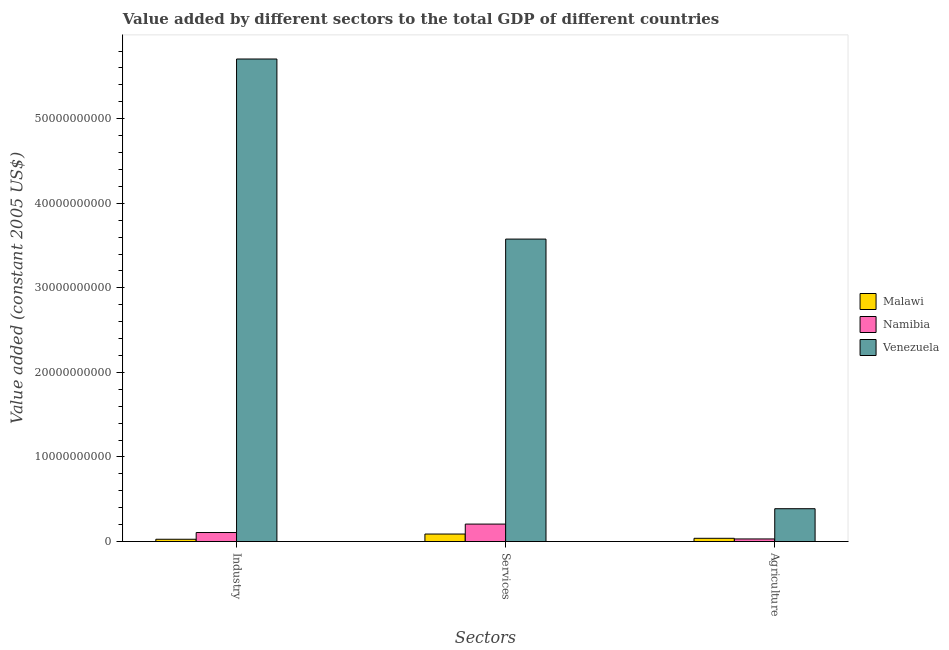How many different coloured bars are there?
Make the answer very short. 3. How many groups of bars are there?
Your answer should be very brief. 3. Are the number of bars per tick equal to the number of legend labels?
Your answer should be compact. Yes. Are the number of bars on each tick of the X-axis equal?
Make the answer very short. Yes. What is the label of the 1st group of bars from the left?
Provide a succinct answer. Industry. What is the value added by industrial sector in Venezuela?
Keep it short and to the point. 5.71e+1. Across all countries, what is the maximum value added by services?
Provide a short and direct response. 3.58e+1. Across all countries, what is the minimum value added by industrial sector?
Provide a short and direct response. 2.72e+08. In which country was the value added by industrial sector maximum?
Your answer should be compact. Venezuela. In which country was the value added by agricultural sector minimum?
Ensure brevity in your answer.  Namibia. What is the total value added by agricultural sector in the graph?
Offer a terse response. 4.58e+09. What is the difference between the value added by services in Venezuela and that in Namibia?
Offer a terse response. 3.37e+1. What is the difference between the value added by industrial sector in Venezuela and the value added by services in Namibia?
Give a very brief answer. 5.50e+1. What is the average value added by services per country?
Your answer should be very brief. 1.29e+1. What is the difference between the value added by services and value added by industrial sector in Venezuela?
Ensure brevity in your answer.  -2.13e+1. What is the ratio of the value added by services in Venezuela to that in Namibia?
Your answer should be compact. 17.31. Is the value added by industrial sector in Malawi less than that in Namibia?
Ensure brevity in your answer.  Yes. Is the difference between the value added by industrial sector in Venezuela and Malawi greater than the difference between the value added by agricultural sector in Venezuela and Malawi?
Provide a short and direct response. Yes. What is the difference between the highest and the second highest value added by services?
Provide a short and direct response. 3.37e+1. What is the difference between the highest and the lowest value added by services?
Keep it short and to the point. 3.49e+1. In how many countries, is the value added by industrial sector greater than the average value added by industrial sector taken over all countries?
Ensure brevity in your answer.  1. Is the sum of the value added by services in Venezuela and Namibia greater than the maximum value added by industrial sector across all countries?
Make the answer very short. No. What does the 3rd bar from the left in Services represents?
Offer a terse response. Venezuela. What does the 3rd bar from the right in Agriculture represents?
Ensure brevity in your answer.  Malawi. How many bars are there?
Provide a succinct answer. 9. Are all the bars in the graph horizontal?
Provide a short and direct response. No. Does the graph contain any zero values?
Your response must be concise. No. Does the graph contain grids?
Offer a terse response. No. What is the title of the graph?
Give a very brief answer. Value added by different sectors to the total GDP of different countries. Does "Benin" appear as one of the legend labels in the graph?
Your answer should be very brief. No. What is the label or title of the X-axis?
Your answer should be compact. Sectors. What is the label or title of the Y-axis?
Ensure brevity in your answer.  Value added (constant 2005 US$). What is the Value added (constant 2005 US$) in Malawi in Industry?
Offer a terse response. 2.72e+08. What is the Value added (constant 2005 US$) in Namibia in Industry?
Offer a terse response. 1.07e+09. What is the Value added (constant 2005 US$) in Venezuela in Industry?
Ensure brevity in your answer.  5.71e+1. What is the Value added (constant 2005 US$) in Malawi in Services?
Ensure brevity in your answer.  8.89e+08. What is the Value added (constant 2005 US$) in Namibia in Services?
Provide a succinct answer. 2.07e+09. What is the Value added (constant 2005 US$) of Venezuela in Services?
Provide a succinct answer. 3.58e+1. What is the Value added (constant 2005 US$) in Malawi in Agriculture?
Offer a very short reply. 3.84e+08. What is the Value added (constant 2005 US$) in Namibia in Agriculture?
Ensure brevity in your answer.  3.09e+08. What is the Value added (constant 2005 US$) in Venezuela in Agriculture?
Offer a terse response. 3.88e+09. Across all Sectors, what is the maximum Value added (constant 2005 US$) of Malawi?
Your response must be concise. 8.89e+08. Across all Sectors, what is the maximum Value added (constant 2005 US$) in Namibia?
Offer a very short reply. 2.07e+09. Across all Sectors, what is the maximum Value added (constant 2005 US$) of Venezuela?
Offer a very short reply. 5.71e+1. Across all Sectors, what is the minimum Value added (constant 2005 US$) of Malawi?
Your answer should be very brief. 2.72e+08. Across all Sectors, what is the minimum Value added (constant 2005 US$) of Namibia?
Offer a terse response. 3.09e+08. Across all Sectors, what is the minimum Value added (constant 2005 US$) in Venezuela?
Provide a succinct answer. 3.88e+09. What is the total Value added (constant 2005 US$) of Malawi in the graph?
Give a very brief answer. 1.55e+09. What is the total Value added (constant 2005 US$) in Namibia in the graph?
Your answer should be very brief. 3.44e+09. What is the total Value added (constant 2005 US$) of Venezuela in the graph?
Your answer should be compact. 9.67e+1. What is the difference between the Value added (constant 2005 US$) in Malawi in Industry and that in Services?
Your response must be concise. -6.18e+08. What is the difference between the Value added (constant 2005 US$) of Namibia in Industry and that in Services?
Make the answer very short. -9.97e+08. What is the difference between the Value added (constant 2005 US$) in Venezuela in Industry and that in Services?
Offer a very short reply. 2.13e+1. What is the difference between the Value added (constant 2005 US$) in Malawi in Industry and that in Agriculture?
Give a very brief answer. -1.13e+08. What is the difference between the Value added (constant 2005 US$) of Namibia in Industry and that in Agriculture?
Make the answer very short. 7.60e+08. What is the difference between the Value added (constant 2005 US$) in Venezuela in Industry and that in Agriculture?
Your response must be concise. 5.32e+1. What is the difference between the Value added (constant 2005 US$) in Malawi in Services and that in Agriculture?
Provide a succinct answer. 5.05e+08. What is the difference between the Value added (constant 2005 US$) of Namibia in Services and that in Agriculture?
Your answer should be compact. 1.76e+09. What is the difference between the Value added (constant 2005 US$) of Venezuela in Services and that in Agriculture?
Your answer should be compact. 3.19e+1. What is the difference between the Value added (constant 2005 US$) in Malawi in Industry and the Value added (constant 2005 US$) in Namibia in Services?
Provide a succinct answer. -1.79e+09. What is the difference between the Value added (constant 2005 US$) in Malawi in Industry and the Value added (constant 2005 US$) in Venezuela in Services?
Keep it short and to the point. -3.55e+1. What is the difference between the Value added (constant 2005 US$) in Namibia in Industry and the Value added (constant 2005 US$) in Venezuela in Services?
Keep it short and to the point. -3.47e+1. What is the difference between the Value added (constant 2005 US$) in Malawi in Industry and the Value added (constant 2005 US$) in Namibia in Agriculture?
Your response must be concise. -3.72e+07. What is the difference between the Value added (constant 2005 US$) in Malawi in Industry and the Value added (constant 2005 US$) in Venezuela in Agriculture?
Offer a very short reply. -3.61e+09. What is the difference between the Value added (constant 2005 US$) of Namibia in Industry and the Value added (constant 2005 US$) of Venezuela in Agriculture?
Make the answer very short. -2.81e+09. What is the difference between the Value added (constant 2005 US$) in Malawi in Services and the Value added (constant 2005 US$) in Namibia in Agriculture?
Provide a short and direct response. 5.80e+08. What is the difference between the Value added (constant 2005 US$) of Malawi in Services and the Value added (constant 2005 US$) of Venezuela in Agriculture?
Your answer should be compact. -2.99e+09. What is the difference between the Value added (constant 2005 US$) in Namibia in Services and the Value added (constant 2005 US$) in Venezuela in Agriculture?
Make the answer very short. -1.82e+09. What is the average Value added (constant 2005 US$) in Malawi per Sectors?
Keep it short and to the point. 5.15e+08. What is the average Value added (constant 2005 US$) of Namibia per Sectors?
Keep it short and to the point. 1.15e+09. What is the average Value added (constant 2005 US$) of Venezuela per Sectors?
Give a very brief answer. 3.22e+1. What is the difference between the Value added (constant 2005 US$) in Malawi and Value added (constant 2005 US$) in Namibia in Industry?
Your answer should be very brief. -7.97e+08. What is the difference between the Value added (constant 2005 US$) in Malawi and Value added (constant 2005 US$) in Venezuela in Industry?
Keep it short and to the point. -5.68e+1. What is the difference between the Value added (constant 2005 US$) in Namibia and Value added (constant 2005 US$) in Venezuela in Industry?
Your response must be concise. -5.60e+1. What is the difference between the Value added (constant 2005 US$) in Malawi and Value added (constant 2005 US$) in Namibia in Services?
Your response must be concise. -1.18e+09. What is the difference between the Value added (constant 2005 US$) of Malawi and Value added (constant 2005 US$) of Venezuela in Services?
Your answer should be compact. -3.49e+1. What is the difference between the Value added (constant 2005 US$) in Namibia and Value added (constant 2005 US$) in Venezuela in Services?
Offer a terse response. -3.37e+1. What is the difference between the Value added (constant 2005 US$) in Malawi and Value added (constant 2005 US$) in Namibia in Agriculture?
Give a very brief answer. 7.54e+07. What is the difference between the Value added (constant 2005 US$) of Malawi and Value added (constant 2005 US$) of Venezuela in Agriculture?
Ensure brevity in your answer.  -3.50e+09. What is the difference between the Value added (constant 2005 US$) in Namibia and Value added (constant 2005 US$) in Venezuela in Agriculture?
Provide a short and direct response. -3.57e+09. What is the ratio of the Value added (constant 2005 US$) of Malawi in Industry to that in Services?
Your answer should be very brief. 0.31. What is the ratio of the Value added (constant 2005 US$) in Namibia in Industry to that in Services?
Give a very brief answer. 0.52. What is the ratio of the Value added (constant 2005 US$) of Venezuela in Industry to that in Services?
Your response must be concise. 1.6. What is the ratio of the Value added (constant 2005 US$) of Malawi in Industry to that in Agriculture?
Ensure brevity in your answer.  0.71. What is the ratio of the Value added (constant 2005 US$) in Namibia in Industry to that in Agriculture?
Your response must be concise. 3.46. What is the ratio of the Value added (constant 2005 US$) of Venezuela in Industry to that in Agriculture?
Your answer should be compact. 14.69. What is the ratio of the Value added (constant 2005 US$) in Malawi in Services to that in Agriculture?
Make the answer very short. 2.31. What is the ratio of the Value added (constant 2005 US$) in Namibia in Services to that in Agriculture?
Offer a very short reply. 6.69. What is the ratio of the Value added (constant 2005 US$) in Venezuela in Services to that in Agriculture?
Ensure brevity in your answer.  9.21. What is the difference between the highest and the second highest Value added (constant 2005 US$) of Malawi?
Your response must be concise. 5.05e+08. What is the difference between the highest and the second highest Value added (constant 2005 US$) in Namibia?
Give a very brief answer. 9.97e+08. What is the difference between the highest and the second highest Value added (constant 2005 US$) in Venezuela?
Provide a succinct answer. 2.13e+1. What is the difference between the highest and the lowest Value added (constant 2005 US$) in Malawi?
Offer a very short reply. 6.18e+08. What is the difference between the highest and the lowest Value added (constant 2005 US$) in Namibia?
Your response must be concise. 1.76e+09. What is the difference between the highest and the lowest Value added (constant 2005 US$) in Venezuela?
Offer a terse response. 5.32e+1. 